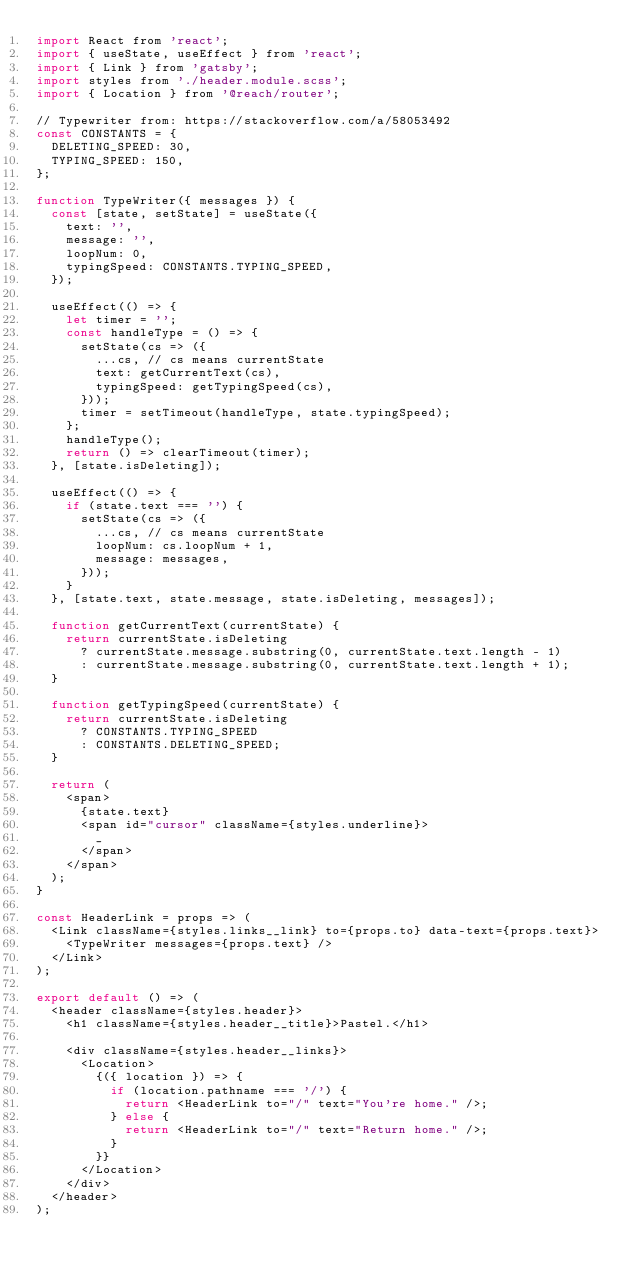Convert code to text. <code><loc_0><loc_0><loc_500><loc_500><_JavaScript_>import React from 'react';
import { useState, useEffect } from 'react';
import { Link } from 'gatsby';
import styles from './header.module.scss';
import { Location } from '@reach/router';

// Typewriter from: https://stackoverflow.com/a/58053492
const CONSTANTS = {
  DELETING_SPEED: 30,
  TYPING_SPEED: 150,
};

function TypeWriter({ messages }) {
  const [state, setState] = useState({
    text: '',
    message: '',
    loopNum: 0,
    typingSpeed: CONSTANTS.TYPING_SPEED,
  });

  useEffect(() => {
    let timer = '';
    const handleType = () => {
      setState(cs => ({
        ...cs, // cs means currentState
        text: getCurrentText(cs),
        typingSpeed: getTypingSpeed(cs),
      }));
      timer = setTimeout(handleType, state.typingSpeed);
    };
    handleType();
    return () => clearTimeout(timer);
  }, [state.isDeleting]);

  useEffect(() => {
    if (state.text === '') {
      setState(cs => ({
        ...cs, // cs means currentState
        loopNum: cs.loopNum + 1,
        message: messages,
      }));
    }
  }, [state.text, state.message, state.isDeleting, messages]);

  function getCurrentText(currentState) {
    return currentState.isDeleting
      ? currentState.message.substring(0, currentState.text.length - 1)
      : currentState.message.substring(0, currentState.text.length + 1);
  }

  function getTypingSpeed(currentState) {
    return currentState.isDeleting
      ? CONSTANTS.TYPING_SPEED
      : CONSTANTS.DELETING_SPEED;
  }

  return (
    <span>
      {state.text}
      <span id="cursor" className={styles.underline}>
        _
      </span>
    </span>
  );
}

const HeaderLink = props => (
  <Link className={styles.links__link} to={props.to} data-text={props.text}>
    <TypeWriter messages={props.text} />
  </Link>
);

export default () => (
  <header className={styles.header}>
    <h1 className={styles.header__title}>Pastel.</h1>

    <div className={styles.header__links}>
      <Location>
        {({ location }) => {
          if (location.pathname === '/') {
            return <HeaderLink to="/" text="You're home." />;
          } else {
            return <HeaderLink to="/" text="Return home." />;
          }
        }}
      </Location>
    </div>
  </header>
);
</code> 